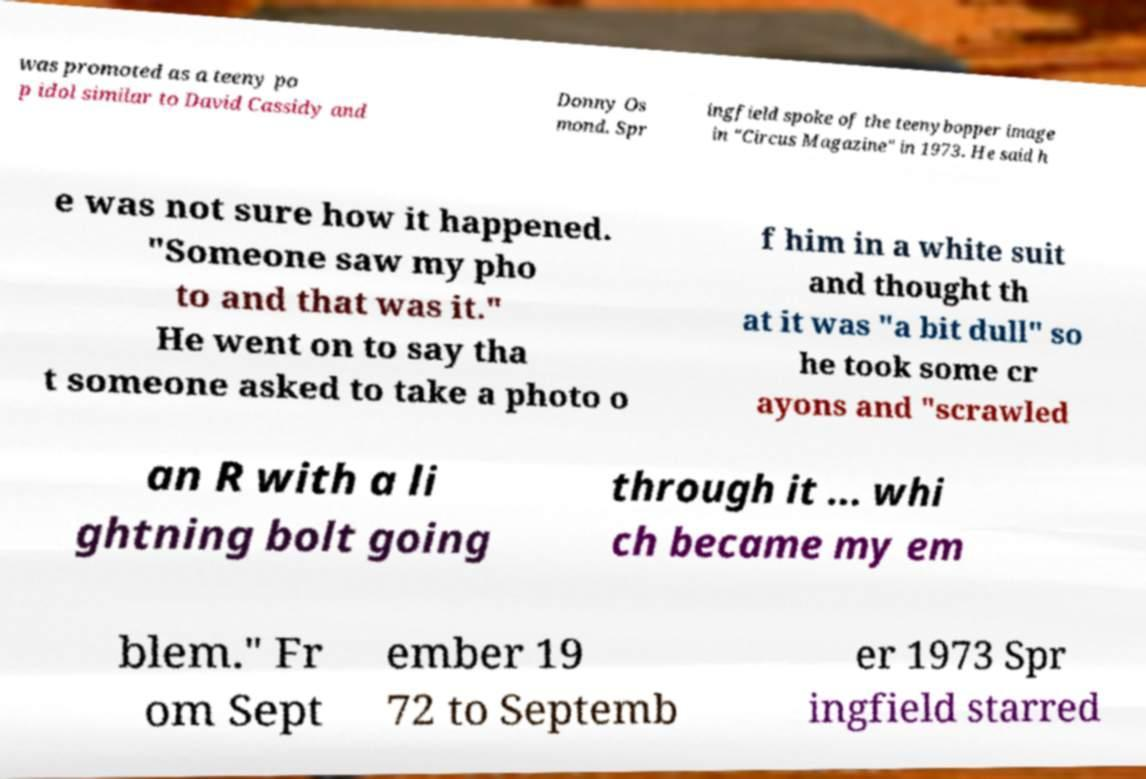There's text embedded in this image that I need extracted. Can you transcribe it verbatim? was promoted as a teeny po p idol similar to David Cassidy and Donny Os mond. Spr ingfield spoke of the teenybopper image in "Circus Magazine" in 1973. He said h e was not sure how it happened. "Someone saw my pho to and that was it." He went on to say tha t someone asked to take a photo o f him in a white suit and thought th at it was "a bit dull" so he took some cr ayons and "scrawled an R with a li ghtning bolt going through it ... whi ch became my em blem." Fr om Sept ember 19 72 to Septemb er 1973 Spr ingfield starred 